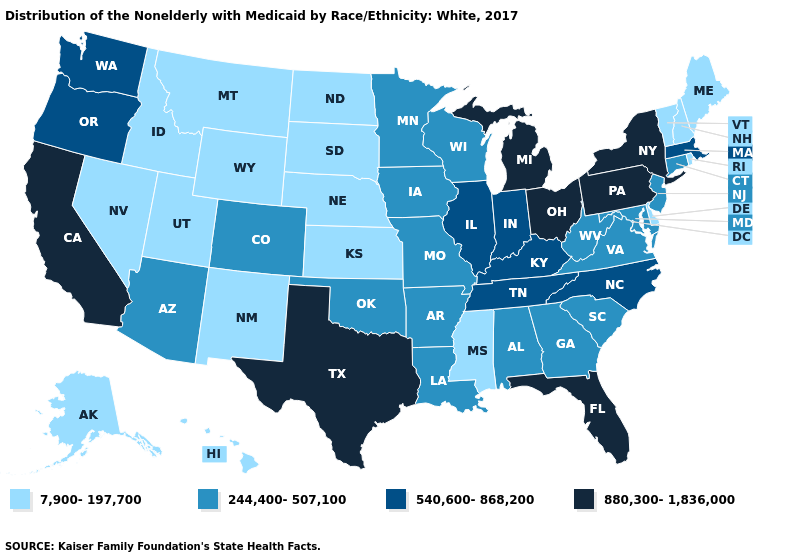Which states hav the highest value in the MidWest?
Be succinct. Michigan, Ohio. What is the value of Arkansas?
Write a very short answer. 244,400-507,100. Which states have the lowest value in the West?
Answer briefly. Alaska, Hawaii, Idaho, Montana, Nevada, New Mexico, Utah, Wyoming. Name the states that have a value in the range 7,900-197,700?
Be succinct. Alaska, Delaware, Hawaii, Idaho, Kansas, Maine, Mississippi, Montana, Nebraska, Nevada, New Hampshire, New Mexico, North Dakota, Rhode Island, South Dakota, Utah, Vermont, Wyoming. How many symbols are there in the legend?
Keep it brief. 4. What is the lowest value in states that border Rhode Island?
Keep it brief. 244,400-507,100. What is the lowest value in the Northeast?
Short answer required. 7,900-197,700. Name the states that have a value in the range 7,900-197,700?
Be succinct. Alaska, Delaware, Hawaii, Idaho, Kansas, Maine, Mississippi, Montana, Nebraska, Nevada, New Hampshire, New Mexico, North Dakota, Rhode Island, South Dakota, Utah, Vermont, Wyoming. Which states have the highest value in the USA?
Quick response, please. California, Florida, Michigan, New York, Ohio, Pennsylvania, Texas. What is the value of New Mexico?
Concise answer only. 7,900-197,700. What is the value of New Hampshire?
Answer briefly. 7,900-197,700. Which states have the lowest value in the MidWest?
Concise answer only. Kansas, Nebraska, North Dakota, South Dakota. Which states have the lowest value in the USA?
Quick response, please. Alaska, Delaware, Hawaii, Idaho, Kansas, Maine, Mississippi, Montana, Nebraska, Nevada, New Hampshire, New Mexico, North Dakota, Rhode Island, South Dakota, Utah, Vermont, Wyoming. What is the highest value in the MidWest ?
Be succinct. 880,300-1,836,000. What is the value of New York?
Short answer required. 880,300-1,836,000. 